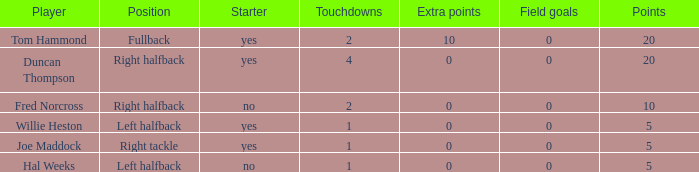What is the greatest number of field goals when more than 1 touchdown occurred and no extra points were scored? 0.0. 